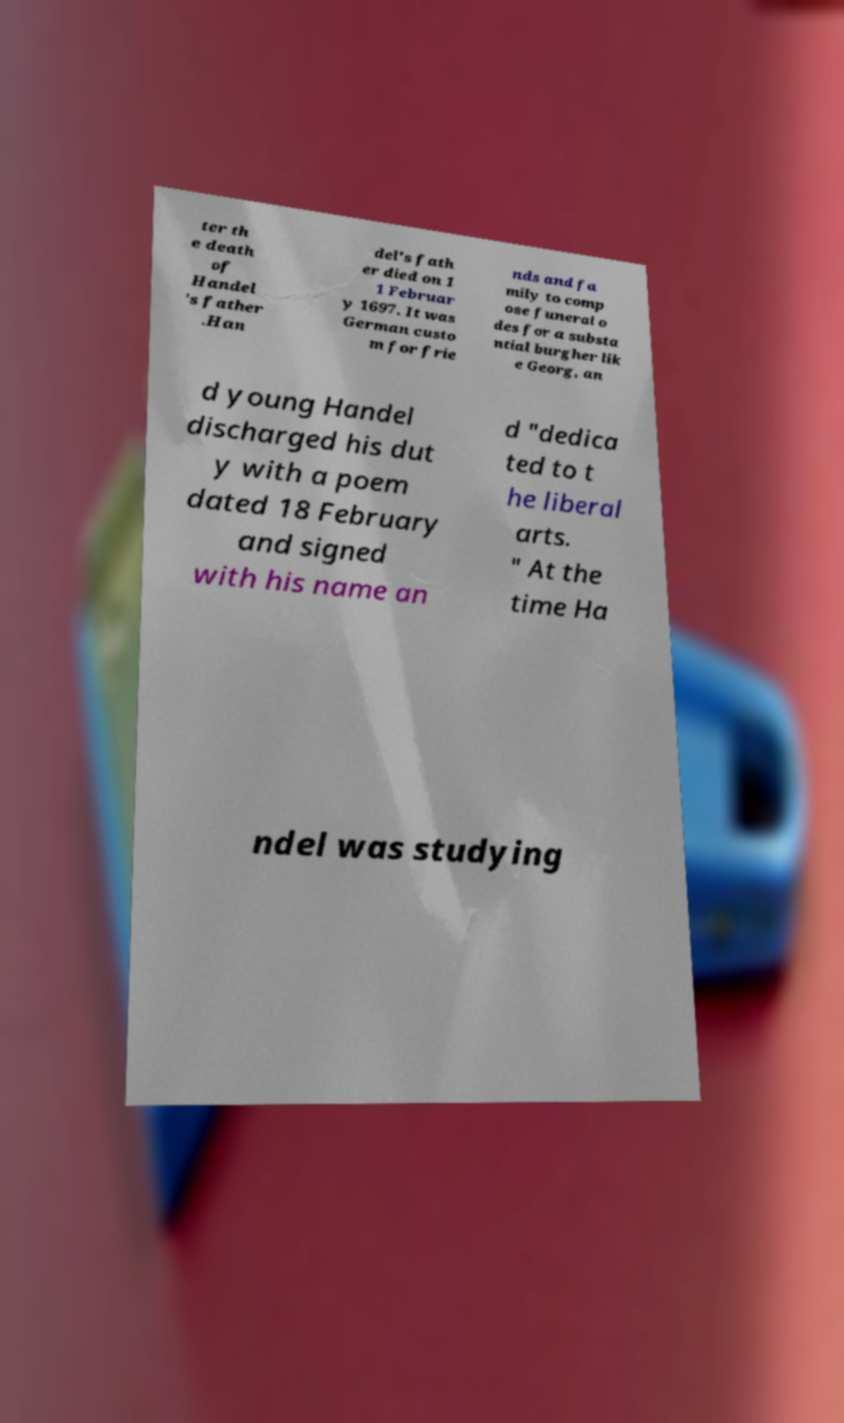Could you assist in decoding the text presented in this image and type it out clearly? ter th e death of Handel 's father .Han del's fath er died on 1 1 Februar y 1697. It was German custo m for frie nds and fa mily to comp ose funeral o des for a substa ntial burgher lik e Georg, an d young Handel discharged his dut y with a poem dated 18 February and signed with his name an d "dedica ted to t he liberal arts. " At the time Ha ndel was studying 